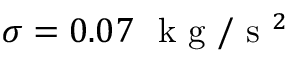<formula> <loc_0><loc_0><loc_500><loc_500>\sigma = 0 . 0 7 { k g } / { s ^ { 2 } }</formula> 